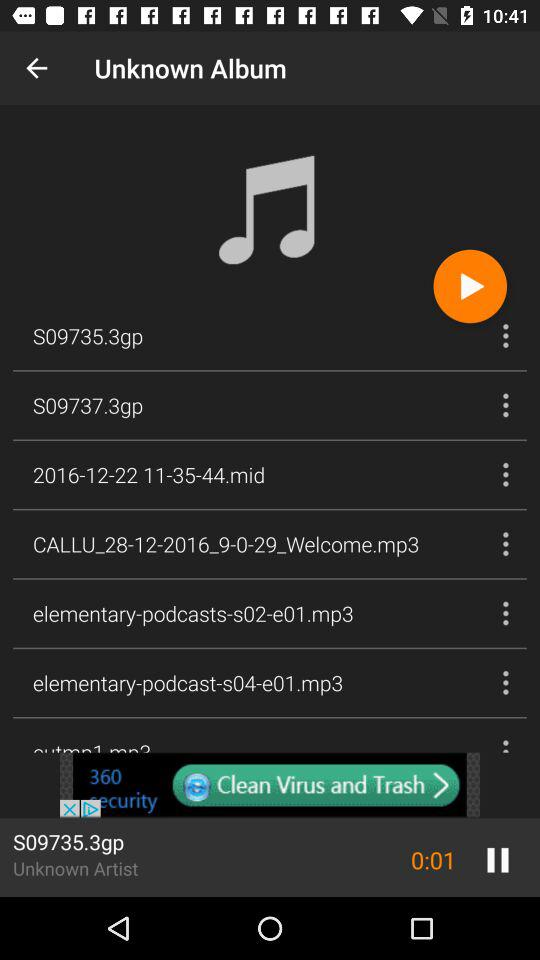What is the duration of the "S09735.3gp" video? The duration of the "S09735.3gp" video is 0:01. 